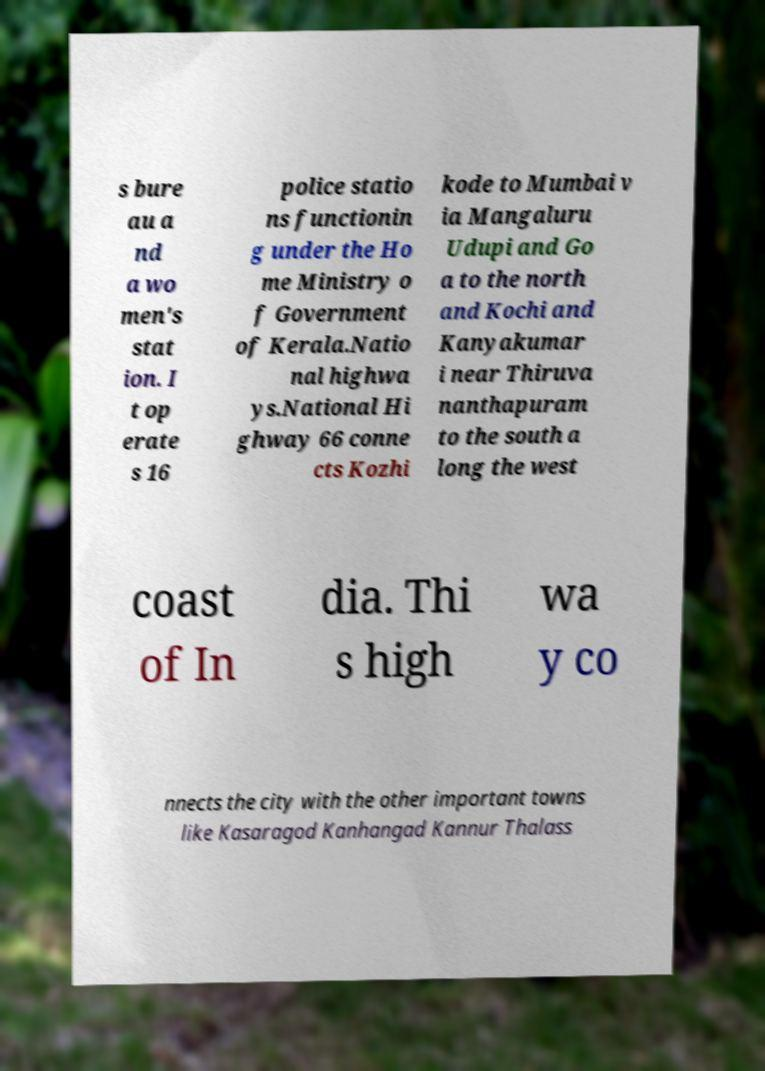For documentation purposes, I need the text within this image transcribed. Could you provide that? s bure au a nd a wo men's stat ion. I t op erate s 16 police statio ns functionin g under the Ho me Ministry o f Government of Kerala.Natio nal highwa ys.National Hi ghway 66 conne cts Kozhi kode to Mumbai v ia Mangaluru Udupi and Go a to the north and Kochi and Kanyakumar i near Thiruva nanthapuram to the south a long the west coast of In dia. Thi s high wa y co nnects the city with the other important towns like Kasaragod Kanhangad Kannur Thalass 